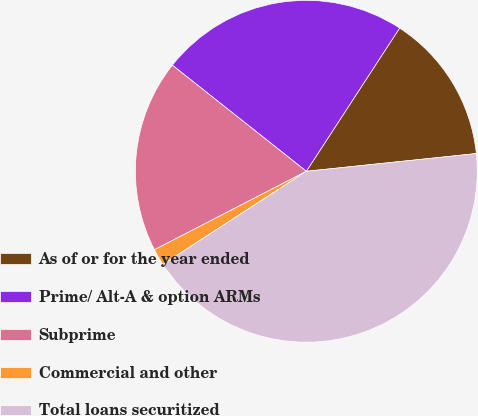Convert chart to OTSL. <chart><loc_0><loc_0><loc_500><loc_500><pie_chart><fcel>As of or for the year ended<fcel>Prime/ Alt-A & option ARMs<fcel>Subprime<fcel>Commercial and other<fcel>Total loans securitized<nl><fcel>14.16%<fcel>23.53%<fcel>18.25%<fcel>1.58%<fcel>42.49%<nl></chart> 